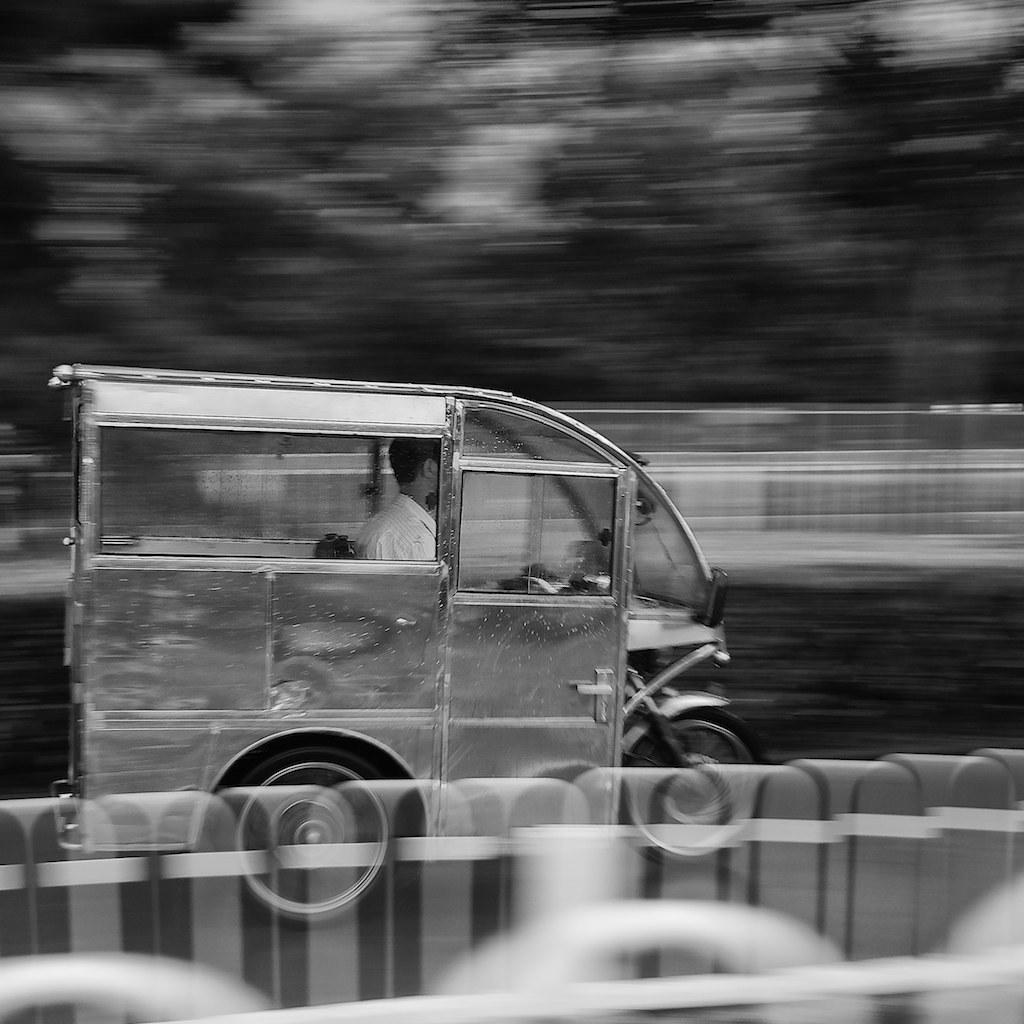What is the main subject of the image? The main subject of the image is a man. What is the man doing in the image? The man is riding a vehicle. What can be observed about the vehicle the man is riding? The vehicle has glass windows. Can you tell me how many grapes are on the man's shirt in the image? There are no grapes visible on the man's shirt in the image. What type of insurance does the vehicle in the image have? There is no information about the vehicle's insurance in the image. 